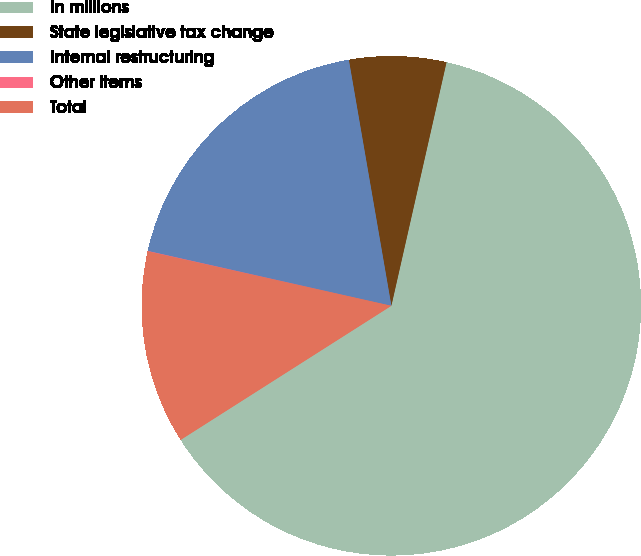<chart> <loc_0><loc_0><loc_500><loc_500><pie_chart><fcel>In millions<fcel>State legislative tax change<fcel>Internal restructuring<fcel>Other items<fcel>Total<nl><fcel>62.43%<fcel>6.27%<fcel>18.75%<fcel>0.03%<fcel>12.51%<nl></chart> 